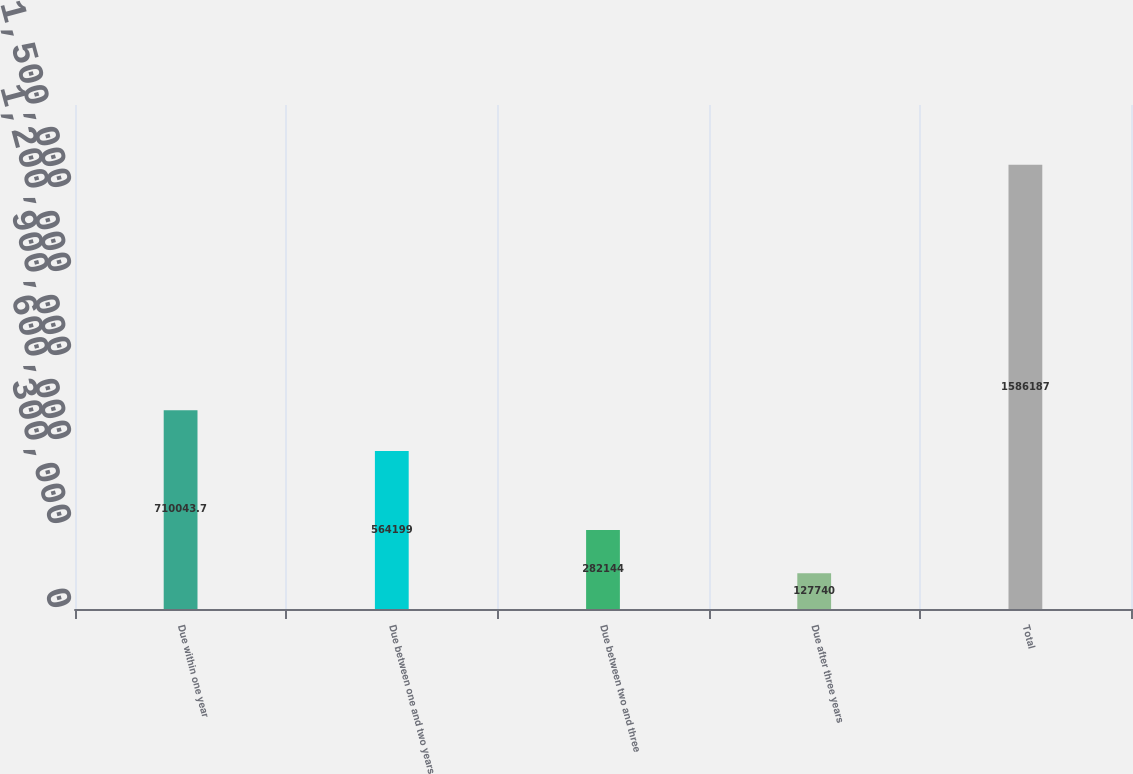Convert chart. <chart><loc_0><loc_0><loc_500><loc_500><bar_chart><fcel>Due within one year<fcel>Due between one and two years<fcel>Due between two and three<fcel>Due after three years<fcel>Total<nl><fcel>710044<fcel>564199<fcel>282144<fcel>127740<fcel>1.58619e+06<nl></chart> 